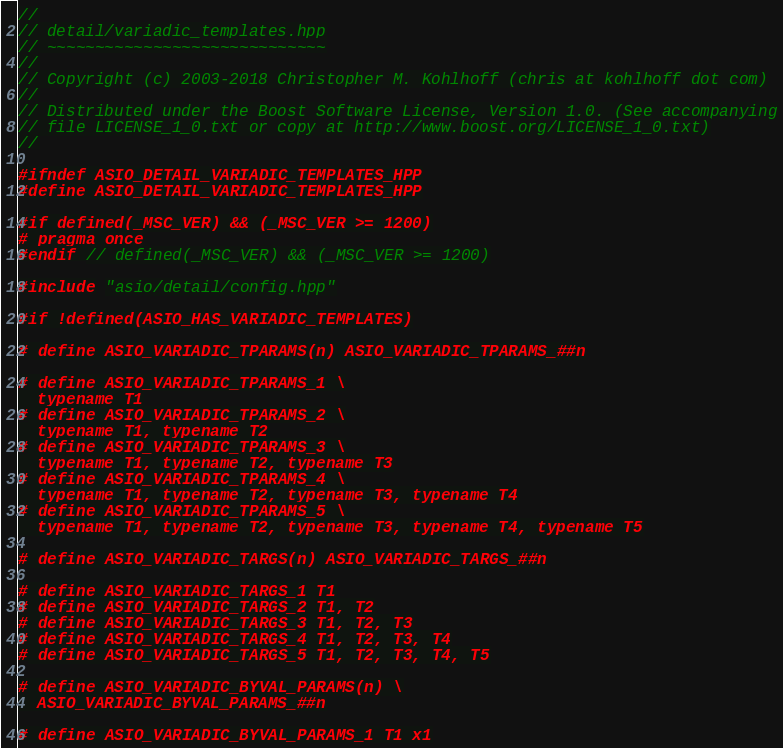Convert code to text. <code><loc_0><loc_0><loc_500><loc_500><_C++_>//
// detail/variadic_templates.hpp
// ~~~~~~~~~~~~~~~~~~~~~~~~~~~~~
//
// Copyright (c) 2003-2018 Christopher M. Kohlhoff (chris at kohlhoff dot com)
//
// Distributed under the Boost Software License, Version 1.0. (See accompanying
// file LICENSE_1_0.txt or copy at http://www.boost.org/LICENSE_1_0.txt)
//

#ifndef ASIO_DETAIL_VARIADIC_TEMPLATES_HPP
#define ASIO_DETAIL_VARIADIC_TEMPLATES_HPP

#if defined(_MSC_VER) && (_MSC_VER >= 1200)
# pragma once
#endif // defined(_MSC_VER) && (_MSC_VER >= 1200)

#include "asio/detail/config.hpp"

#if !defined(ASIO_HAS_VARIADIC_TEMPLATES)

# define ASIO_VARIADIC_TPARAMS(n) ASIO_VARIADIC_TPARAMS_##n

# define ASIO_VARIADIC_TPARAMS_1 \
  typename T1
# define ASIO_VARIADIC_TPARAMS_2 \
  typename T1, typename T2
# define ASIO_VARIADIC_TPARAMS_3 \
  typename T1, typename T2, typename T3
# define ASIO_VARIADIC_TPARAMS_4 \
  typename T1, typename T2, typename T3, typename T4
# define ASIO_VARIADIC_TPARAMS_5 \
  typename T1, typename T2, typename T3, typename T4, typename T5

# define ASIO_VARIADIC_TARGS(n) ASIO_VARIADIC_TARGS_##n

# define ASIO_VARIADIC_TARGS_1 T1
# define ASIO_VARIADIC_TARGS_2 T1, T2
# define ASIO_VARIADIC_TARGS_3 T1, T2, T3
# define ASIO_VARIADIC_TARGS_4 T1, T2, T3, T4
# define ASIO_VARIADIC_TARGS_5 T1, T2, T3, T4, T5

# define ASIO_VARIADIC_BYVAL_PARAMS(n) \
  ASIO_VARIADIC_BYVAL_PARAMS_##n

# define ASIO_VARIADIC_BYVAL_PARAMS_1 T1 x1</code> 